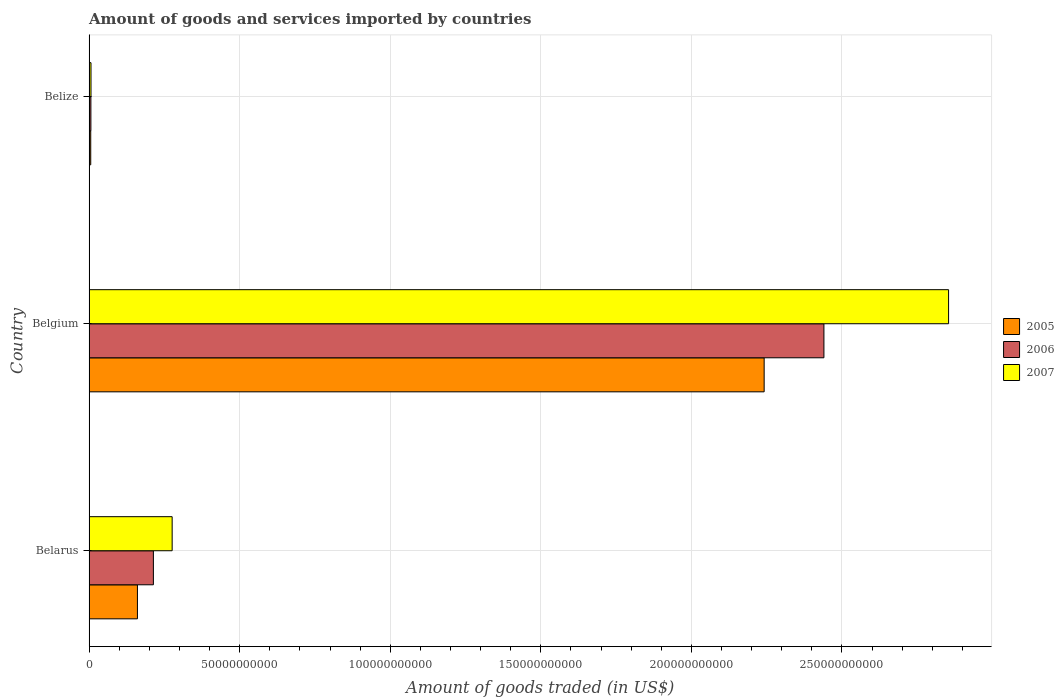Are the number of bars on each tick of the Y-axis equal?
Ensure brevity in your answer.  Yes. In how many cases, is the number of bars for a given country not equal to the number of legend labels?
Your response must be concise. 0. What is the total amount of goods and services imported in 2006 in Belize?
Your answer should be compact. 5.98e+08. Across all countries, what is the maximum total amount of goods and services imported in 2006?
Ensure brevity in your answer.  2.44e+11. Across all countries, what is the minimum total amount of goods and services imported in 2005?
Your answer should be very brief. 5.44e+08. In which country was the total amount of goods and services imported in 2007 minimum?
Provide a short and direct response. Belize. What is the total total amount of goods and services imported in 2007 in the graph?
Provide a short and direct response. 3.14e+11. What is the difference between the total amount of goods and services imported in 2007 in Belgium and that in Belize?
Provide a short and direct response. 2.85e+11. What is the difference between the total amount of goods and services imported in 2006 in Belarus and the total amount of goods and services imported in 2007 in Belgium?
Keep it short and to the point. -2.64e+11. What is the average total amount of goods and services imported in 2005 per country?
Provide a short and direct response. 8.03e+1. What is the difference between the total amount of goods and services imported in 2007 and total amount of goods and services imported in 2005 in Belize?
Your answer should be compact. 9.05e+07. What is the ratio of the total amount of goods and services imported in 2005 in Belgium to that in Belize?
Offer a terse response. 411.92. Is the total amount of goods and services imported in 2006 in Belgium less than that in Belize?
Offer a terse response. No. Is the difference between the total amount of goods and services imported in 2007 in Belgium and Belize greater than the difference between the total amount of goods and services imported in 2005 in Belgium and Belize?
Offer a very short reply. Yes. What is the difference between the highest and the second highest total amount of goods and services imported in 2006?
Make the answer very short. 2.23e+11. What is the difference between the highest and the lowest total amount of goods and services imported in 2006?
Offer a terse response. 2.43e+11. Is the sum of the total amount of goods and services imported in 2006 in Belarus and Belize greater than the maximum total amount of goods and services imported in 2007 across all countries?
Your answer should be very brief. No. What does the 2nd bar from the top in Belize represents?
Give a very brief answer. 2006. What does the 1st bar from the bottom in Belize represents?
Make the answer very short. 2005. What is the difference between two consecutive major ticks on the X-axis?
Your answer should be very brief. 5.00e+1. Does the graph contain grids?
Offer a terse response. Yes. How are the legend labels stacked?
Your answer should be compact. Vertical. What is the title of the graph?
Make the answer very short. Amount of goods and services imported by countries. Does "2013" appear as one of the legend labels in the graph?
Offer a very short reply. No. What is the label or title of the X-axis?
Offer a terse response. Amount of goods traded (in US$). What is the label or title of the Y-axis?
Ensure brevity in your answer.  Country. What is the Amount of goods traded (in US$) in 2005 in Belarus?
Offer a very short reply. 1.61e+1. What is the Amount of goods traded (in US$) of 2006 in Belarus?
Your response must be concise. 2.14e+1. What is the Amount of goods traded (in US$) of 2007 in Belarus?
Your answer should be very brief. 2.76e+1. What is the Amount of goods traded (in US$) in 2005 in Belgium?
Your answer should be compact. 2.24e+11. What is the Amount of goods traded (in US$) of 2006 in Belgium?
Your answer should be compact. 2.44e+11. What is the Amount of goods traded (in US$) of 2007 in Belgium?
Make the answer very short. 2.85e+11. What is the Amount of goods traded (in US$) of 2005 in Belize?
Provide a succinct answer. 5.44e+08. What is the Amount of goods traded (in US$) in 2006 in Belize?
Your response must be concise. 5.98e+08. What is the Amount of goods traded (in US$) of 2007 in Belize?
Keep it short and to the point. 6.35e+08. Across all countries, what is the maximum Amount of goods traded (in US$) in 2005?
Offer a terse response. 2.24e+11. Across all countries, what is the maximum Amount of goods traded (in US$) in 2006?
Make the answer very short. 2.44e+11. Across all countries, what is the maximum Amount of goods traded (in US$) of 2007?
Your response must be concise. 2.85e+11. Across all countries, what is the minimum Amount of goods traded (in US$) in 2005?
Your answer should be compact. 5.44e+08. Across all countries, what is the minimum Amount of goods traded (in US$) in 2006?
Offer a terse response. 5.98e+08. Across all countries, what is the minimum Amount of goods traded (in US$) of 2007?
Offer a very short reply. 6.35e+08. What is the total Amount of goods traded (in US$) of 2005 in the graph?
Provide a short and direct response. 2.41e+11. What is the total Amount of goods traded (in US$) in 2006 in the graph?
Provide a short and direct response. 2.66e+11. What is the total Amount of goods traded (in US$) of 2007 in the graph?
Ensure brevity in your answer.  3.14e+11. What is the difference between the Amount of goods traded (in US$) of 2005 in Belarus and that in Belgium?
Your answer should be very brief. -2.08e+11. What is the difference between the Amount of goods traded (in US$) of 2006 in Belarus and that in Belgium?
Give a very brief answer. -2.23e+11. What is the difference between the Amount of goods traded (in US$) of 2007 in Belarus and that in Belgium?
Your answer should be very brief. -2.58e+11. What is the difference between the Amount of goods traded (in US$) in 2005 in Belarus and that in Belize?
Keep it short and to the point. 1.55e+1. What is the difference between the Amount of goods traded (in US$) in 2006 in Belarus and that in Belize?
Your response must be concise. 2.08e+1. What is the difference between the Amount of goods traded (in US$) of 2007 in Belarus and that in Belize?
Ensure brevity in your answer.  2.69e+1. What is the difference between the Amount of goods traded (in US$) in 2005 in Belgium and that in Belize?
Provide a short and direct response. 2.24e+11. What is the difference between the Amount of goods traded (in US$) of 2006 in Belgium and that in Belize?
Your response must be concise. 2.43e+11. What is the difference between the Amount of goods traded (in US$) in 2007 in Belgium and that in Belize?
Offer a very short reply. 2.85e+11. What is the difference between the Amount of goods traded (in US$) of 2005 in Belarus and the Amount of goods traded (in US$) of 2006 in Belgium?
Make the answer very short. -2.28e+11. What is the difference between the Amount of goods traded (in US$) in 2005 in Belarus and the Amount of goods traded (in US$) in 2007 in Belgium?
Your response must be concise. -2.69e+11. What is the difference between the Amount of goods traded (in US$) in 2006 in Belarus and the Amount of goods traded (in US$) in 2007 in Belgium?
Make the answer very short. -2.64e+11. What is the difference between the Amount of goods traded (in US$) of 2005 in Belarus and the Amount of goods traded (in US$) of 2006 in Belize?
Ensure brevity in your answer.  1.55e+1. What is the difference between the Amount of goods traded (in US$) in 2005 in Belarus and the Amount of goods traded (in US$) in 2007 in Belize?
Keep it short and to the point. 1.54e+1. What is the difference between the Amount of goods traded (in US$) of 2006 in Belarus and the Amount of goods traded (in US$) of 2007 in Belize?
Provide a short and direct response. 2.07e+1. What is the difference between the Amount of goods traded (in US$) of 2005 in Belgium and the Amount of goods traded (in US$) of 2006 in Belize?
Give a very brief answer. 2.24e+11. What is the difference between the Amount of goods traded (in US$) of 2005 in Belgium and the Amount of goods traded (in US$) of 2007 in Belize?
Ensure brevity in your answer.  2.24e+11. What is the difference between the Amount of goods traded (in US$) in 2006 in Belgium and the Amount of goods traded (in US$) in 2007 in Belize?
Give a very brief answer. 2.43e+11. What is the average Amount of goods traded (in US$) of 2005 per country?
Keep it short and to the point. 8.03e+1. What is the average Amount of goods traded (in US$) in 2006 per country?
Make the answer very short. 8.87e+1. What is the average Amount of goods traded (in US$) in 2007 per country?
Make the answer very short. 1.05e+11. What is the difference between the Amount of goods traded (in US$) in 2005 and Amount of goods traded (in US$) in 2006 in Belarus?
Provide a succinct answer. -5.30e+09. What is the difference between the Amount of goods traded (in US$) of 2005 and Amount of goods traded (in US$) of 2007 in Belarus?
Provide a short and direct response. -1.15e+1. What is the difference between the Amount of goods traded (in US$) of 2006 and Amount of goods traded (in US$) of 2007 in Belarus?
Provide a succinct answer. -6.23e+09. What is the difference between the Amount of goods traded (in US$) in 2005 and Amount of goods traded (in US$) in 2006 in Belgium?
Your answer should be very brief. -1.98e+1. What is the difference between the Amount of goods traded (in US$) of 2005 and Amount of goods traded (in US$) of 2007 in Belgium?
Your answer should be very brief. -6.12e+1. What is the difference between the Amount of goods traded (in US$) in 2006 and Amount of goods traded (in US$) in 2007 in Belgium?
Offer a very short reply. -4.14e+1. What is the difference between the Amount of goods traded (in US$) in 2005 and Amount of goods traded (in US$) in 2006 in Belize?
Give a very brief answer. -5.37e+07. What is the difference between the Amount of goods traded (in US$) in 2005 and Amount of goods traded (in US$) in 2007 in Belize?
Make the answer very short. -9.05e+07. What is the difference between the Amount of goods traded (in US$) in 2006 and Amount of goods traded (in US$) in 2007 in Belize?
Provide a succinct answer. -3.68e+07. What is the ratio of the Amount of goods traded (in US$) of 2005 in Belarus to that in Belgium?
Make the answer very short. 0.07. What is the ratio of the Amount of goods traded (in US$) in 2006 in Belarus to that in Belgium?
Ensure brevity in your answer.  0.09. What is the ratio of the Amount of goods traded (in US$) in 2007 in Belarus to that in Belgium?
Provide a succinct answer. 0.1. What is the ratio of the Amount of goods traded (in US$) of 2005 in Belarus to that in Belize?
Offer a very short reply. 29.5. What is the ratio of the Amount of goods traded (in US$) in 2006 in Belarus to that in Belize?
Offer a terse response. 35.71. What is the ratio of the Amount of goods traded (in US$) of 2007 in Belarus to that in Belize?
Offer a terse response. 43.46. What is the ratio of the Amount of goods traded (in US$) of 2005 in Belgium to that in Belize?
Offer a terse response. 411.92. What is the ratio of the Amount of goods traded (in US$) in 2006 in Belgium to that in Belize?
Your answer should be very brief. 408.14. What is the ratio of the Amount of goods traded (in US$) of 2007 in Belgium to that in Belize?
Keep it short and to the point. 449.67. What is the difference between the highest and the second highest Amount of goods traded (in US$) of 2005?
Ensure brevity in your answer.  2.08e+11. What is the difference between the highest and the second highest Amount of goods traded (in US$) in 2006?
Your response must be concise. 2.23e+11. What is the difference between the highest and the second highest Amount of goods traded (in US$) of 2007?
Make the answer very short. 2.58e+11. What is the difference between the highest and the lowest Amount of goods traded (in US$) of 2005?
Your answer should be compact. 2.24e+11. What is the difference between the highest and the lowest Amount of goods traded (in US$) of 2006?
Your answer should be compact. 2.43e+11. What is the difference between the highest and the lowest Amount of goods traded (in US$) of 2007?
Your answer should be very brief. 2.85e+11. 